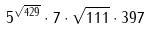Convert formula to latex. <formula><loc_0><loc_0><loc_500><loc_500>5 ^ { \sqrt { 4 2 9 } } \cdot 7 \cdot \sqrt { 1 1 1 } \cdot 3 9 7</formula> 